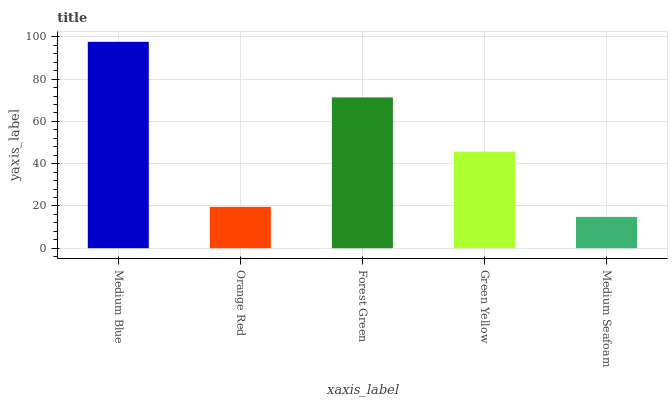Is Medium Seafoam the minimum?
Answer yes or no. Yes. Is Medium Blue the maximum?
Answer yes or no. Yes. Is Orange Red the minimum?
Answer yes or no. No. Is Orange Red the maximum?
Answer yes or no. No. Is Medium Blue greater than Orange Red?
Answer yes or no. Yes. Is Orange Red less than Medium Blue?
Answer yes or no. Yes. Is Orange Red greater than Medium Blue?
Answer yes or no. No. Is Medium Blue less than Orange Red?
Answer yes or no. No. Is Green Yellow the high median?
Answer yes or no. Yes. Is Green Yellow the low median?
Answer yes or no. Yes. Is Forest Green the high median?
Answer yes or no. No. Is Orange Red the low median?
Answer yes or no. No. 